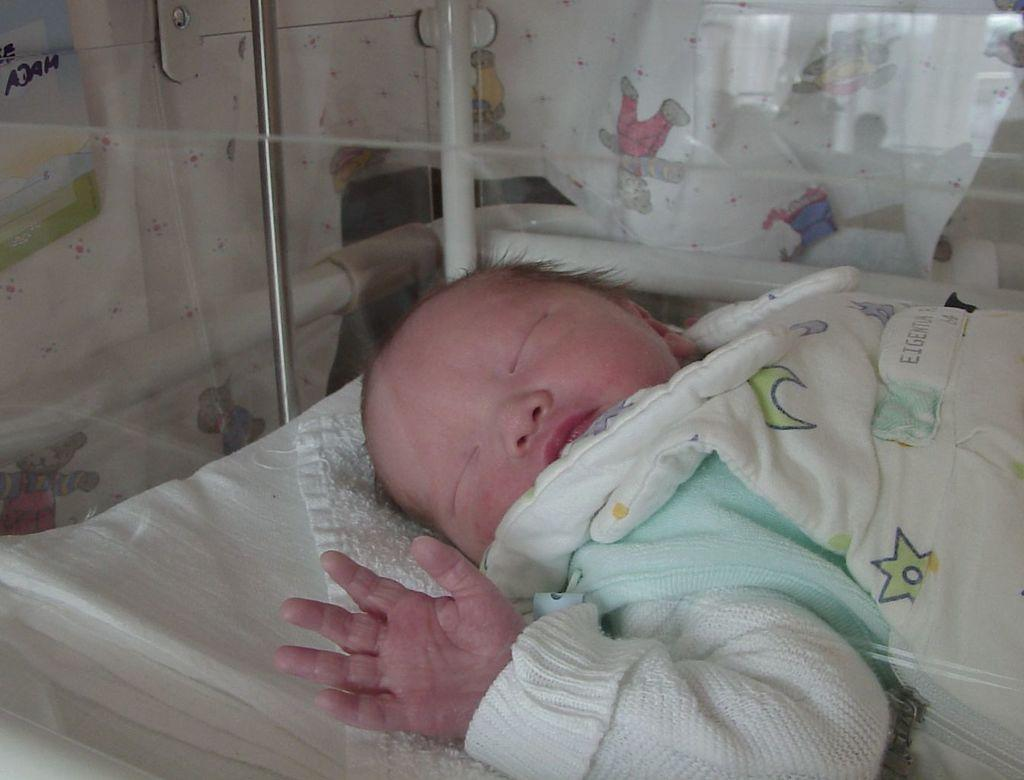What is visible through the glass in the image? A baby is sleeping in the image, as seen through the glass. What object is present in the image that is made of glass? There is a glass in the image. What is located at the bottom of the image? There is a cloth at the bottom of the image. Can you tell me what the father is playing in the band in the image? There is no father or band present in the image; it features a glass and a sleeping baby. What type of instrument is the partner playing in the image? There is no partner or instrument present in the image. 